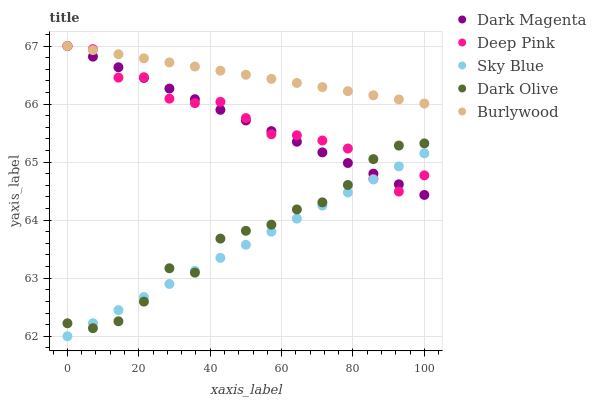Does Sky Blue have the minimum area under the curve?
Answer yes or no. Yes. Does Burlywood have the maximum area under the curve?
Answer yes or no. Yes. Does Deep Pink have the minimum area under the curve?
Answer yes or no. No. Does Deep Pink have the maximum area under the curve?
Answer yes or no. No. Is Sky Blue the smoothest?
Answer yes or no. Yes. Is Deep Pink the roughest?
Answer yes or no. Yes. Is Deep Pink the smoothest?
Answer yes or no. No. Is Sky Blue the roughest?
Answer yes or no. No. Does Sky Blue have the lowest value?
Answer yes or no. Yes. Does Deep Pink have the lowest value?
Answer yes or no. No. Does Burlywood have the highest value?
Answer yes or no. Yes. Does Sky Blue have the highest value?
Answer yes or no. No. Is Sky Blue less than Burlywood?
Answer yes or no. Yes. Is Burlywood greater than Dark Olive?
Answer yes or no. Yes. Does Burlywood intersect Deep Pink?
Answer yes or no. Yes. Is Burlywood less than Deep Pink?
Answer yes or no. No. Is Burlywood greater than Deep Pink?
Answer yes or no. No. Does Sky Blue intersect Burlywood?
Answer yes or no. No. 